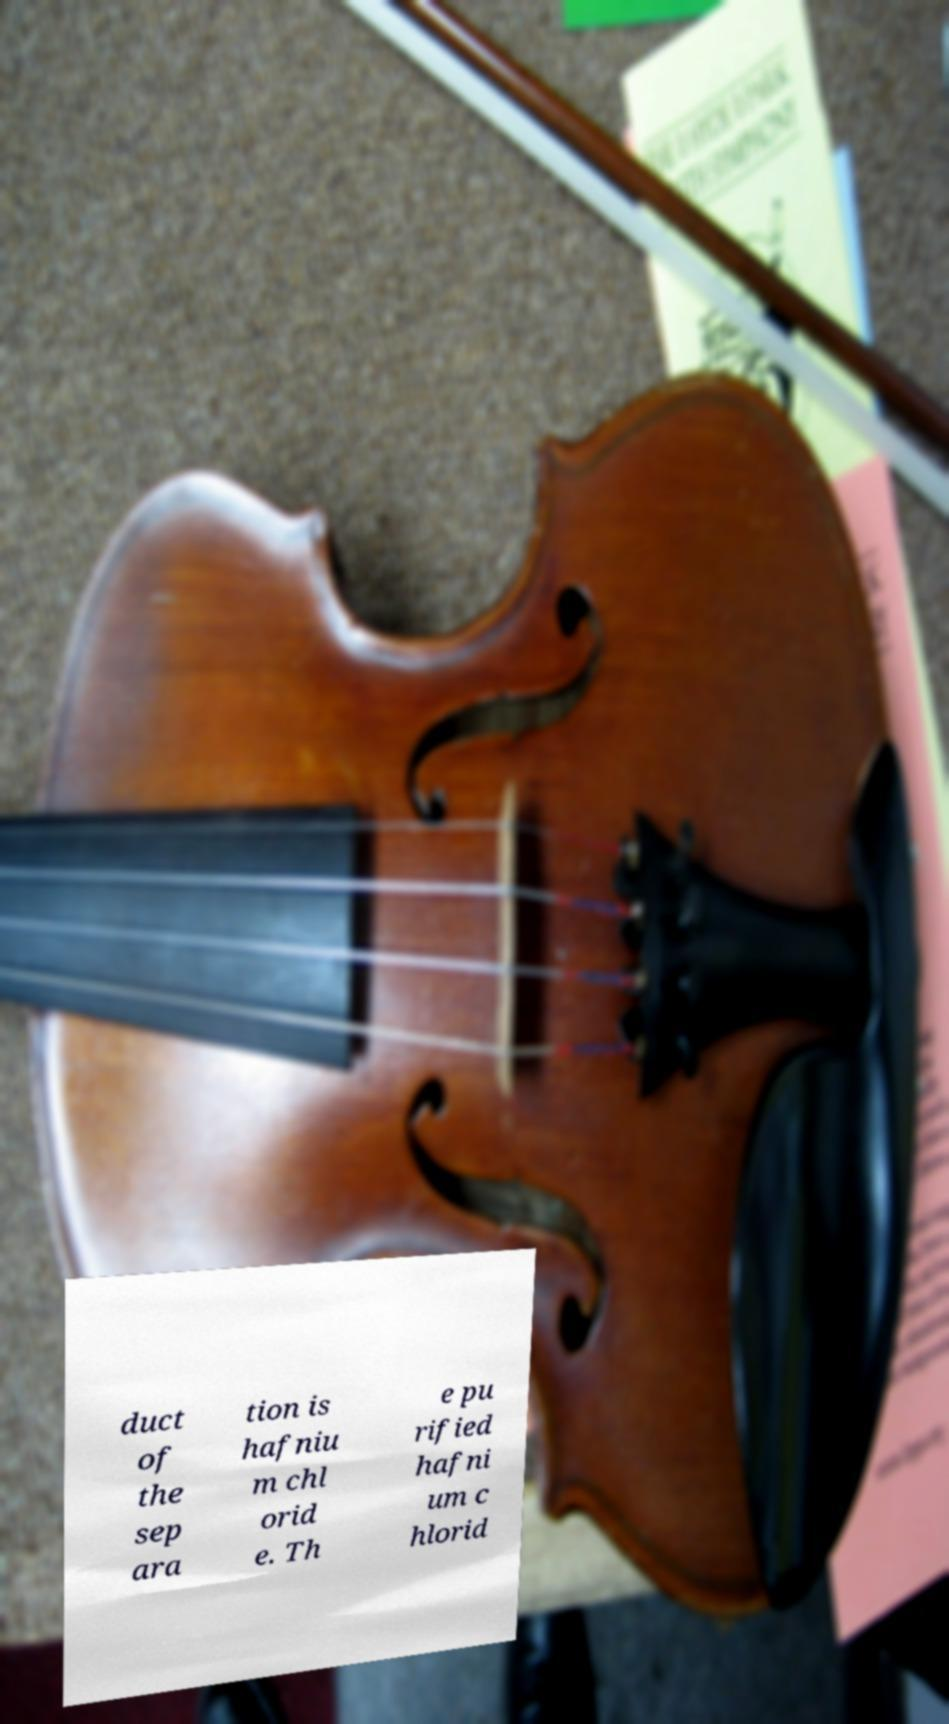Please identify and transcribe the text found in this image. duct of the sep ara tion is hafniu m chl orid e. Th e pu rified hafni um c hlorid 